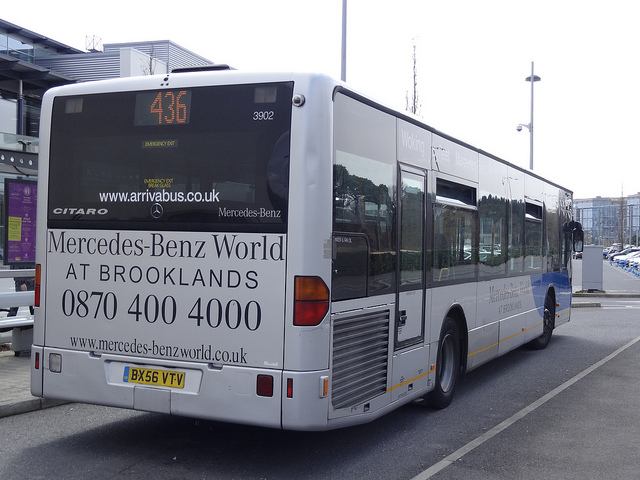Extract all visible text content from this image. 436 www.arrivabus.co.uk CITARO BROOKLANDS 3902 BX VTV X56 www.mercedes-benzworld.co.uk 4000 400 0870 AT World Benz Mercedes- Benz Mercedes- 